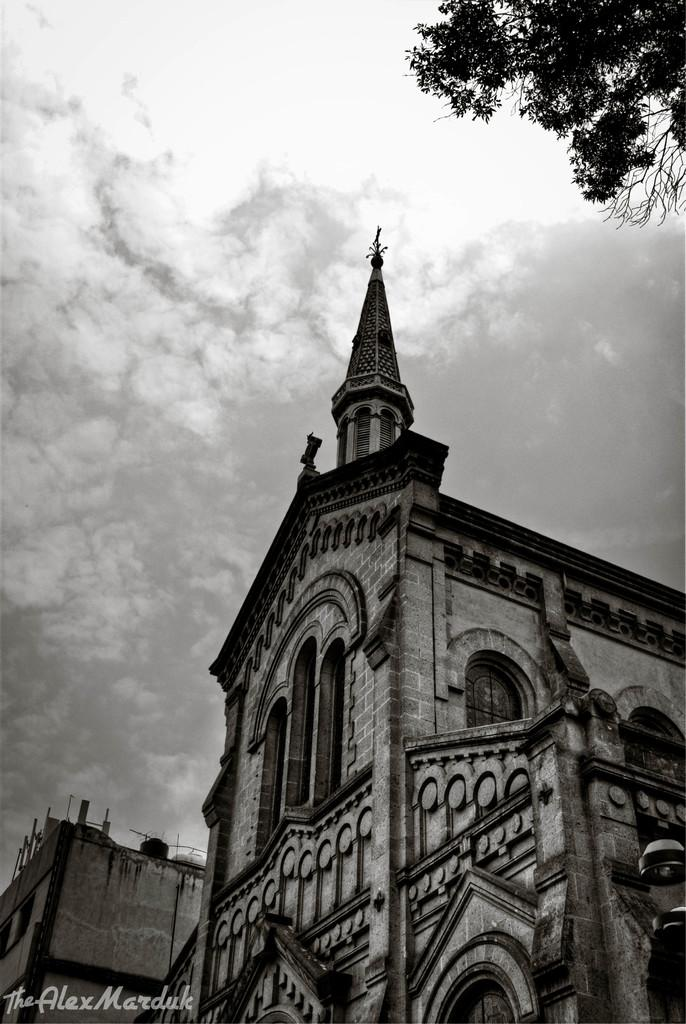What is the color scheme of the image? The image is black and white. What type of building can be seen in the image? There is a church in the image. Where is the tree located in the image? The tree is in the top right corner of the image. What is present in the bottom left corner of the image? There is text in the bottom left corner of the image. How many friends are sitting on the church steps in the image? There are no friends or church steps present in the image. What type of fly is buzzing around the tree in the image? There are no flies present in the image. 